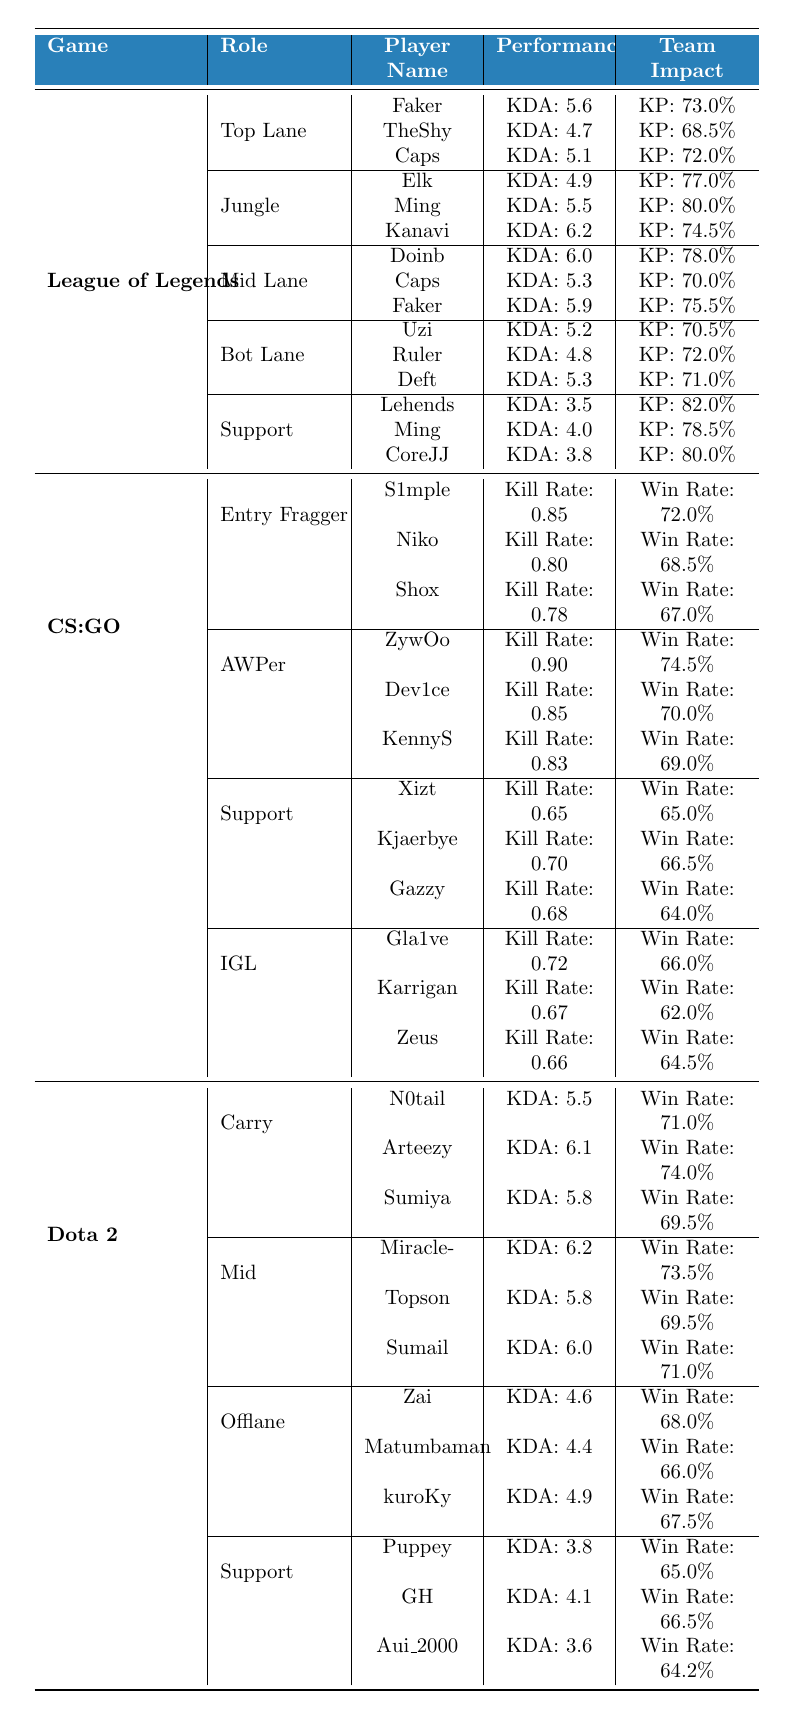What is the KDA of the player 'Faker' in League of Legends? The table shows under the League of Legends category that in the Top Lane section, the player 'Faker' has a KDA value of 5.6.
Answer: 5.6 Which player has the highest Kill Participation in League of Legends as a Support? By examining the Support section, 'Lehends' has a Kill Participation of 82.0%, which is the highest among the listed Support players.
Answer: Lehends What is the average KDA for the Mid Lane players in League of Legends? The KDAs for the three Mid Lane players (Doinb, Caps, Faker) are 6.0, 5.3, and 5.9 respectively. The total is 6.0 + 5.3 + 5.9 = 17.2, and dividing by 3 gives 17.2 / 3 = 5.73.
Answer: 5.73 Who has a higher Win Rate, the best AWPer or the best Entry Fragger in CS:GO? The best AWPer is 'ZywOo' with a Win Rate of 74.5%, and the best Entry Fragger is 'S1mple' with a Win Rate of 72.0%. Since 74.5% is greater than 72.0%, ZywOo has a higher Win Rate.
Answer: ZywOo Is the KDA of the player 'Arteezy' greater than 5.7 in Dota 2? 'Arteezy' has a KDA of 6.1 in the Carry role. Since 6.1 is greater than 5.7, this statement is true.
Answer: Yes What is the total number of players listed in the Jungle role for League of Legends? The Jungle section lists 'Elk', 'Ming', and 'Kanavi', which totals to 3 players.
Answer: 3 Which player from the Offlane role in Dota 2 has the highest KDA? The KDA values of the Offlane players are Zai (4.6), Matumbaman (4.4), and kuroKy (4.9). Since 4.9 (kuroKy) is the highest of these values, kuroKy has the highest KDA.
Answer: kuroKy What is the difference in Win Rate between the best Carry and the best Offlane player in Dota 2? The best Carry player 'Arteezy' has a Win Rate of 74.0%, while the best Offlane player 'kuroKy' has a Win Rate of 67.5%. The difference is 74.0% - 67.5% = 6.5%.
Answer: 6.5% Who has the lowest Kill Rate among the players in the Support role of CS:GO? Looking at the Kill Rate of Support players: Xizt (0.65), Kjaerbye (0.70), and Gazzy (0.68), Xizt has the lowest Kill Rate among these players.
Answer: Xizt Is there any player from the Mid role in Dota 2 with a KDA over 6.0? From the Mid section, 'Miracle-' has a KDA of 6.2, which is over 6.0, thus confirming that there is indeed such a player.
Answer: Yes 